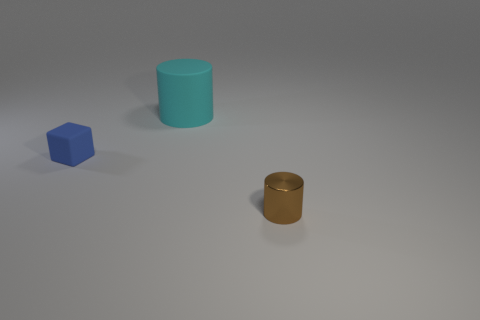There is a rubber thing that is on the right side of the small blue cube; are there any large matte cylinders that are behind it?
Make the answer very short. No. There is a cylinder to the left of the brown object; is it the same color as the matte object that is left of the matte cylinder?
Offer a terse response. No. The cube that is the same size as the brown metallic object is what color?
Offer a terse response. Blue. Is the number of small objects in front of the rubber cube the same as the number of tiny brown metallic objects in front of the small cylinder?
Provide a short and direct response. No. What material is the tiny thing on the left side of the tiny object in front of the tiny blue thing?
Keep it short and to the point. Rubber. How many objects are rubber spheres or small brown cylinders?
Give a very brief answer. 1. Is the number of big purple blocks less than the number of small cylinders?
Provide a short and direct response. Yes. There is a blue object that is the same material as the cyan cylinder; what size is it?
Give a very brief answer. Small. How big is the rubber block?
Your answer should be compact. Small. The big cyan matte object has what shape?
Keep it short and to the point. Cylinder. 